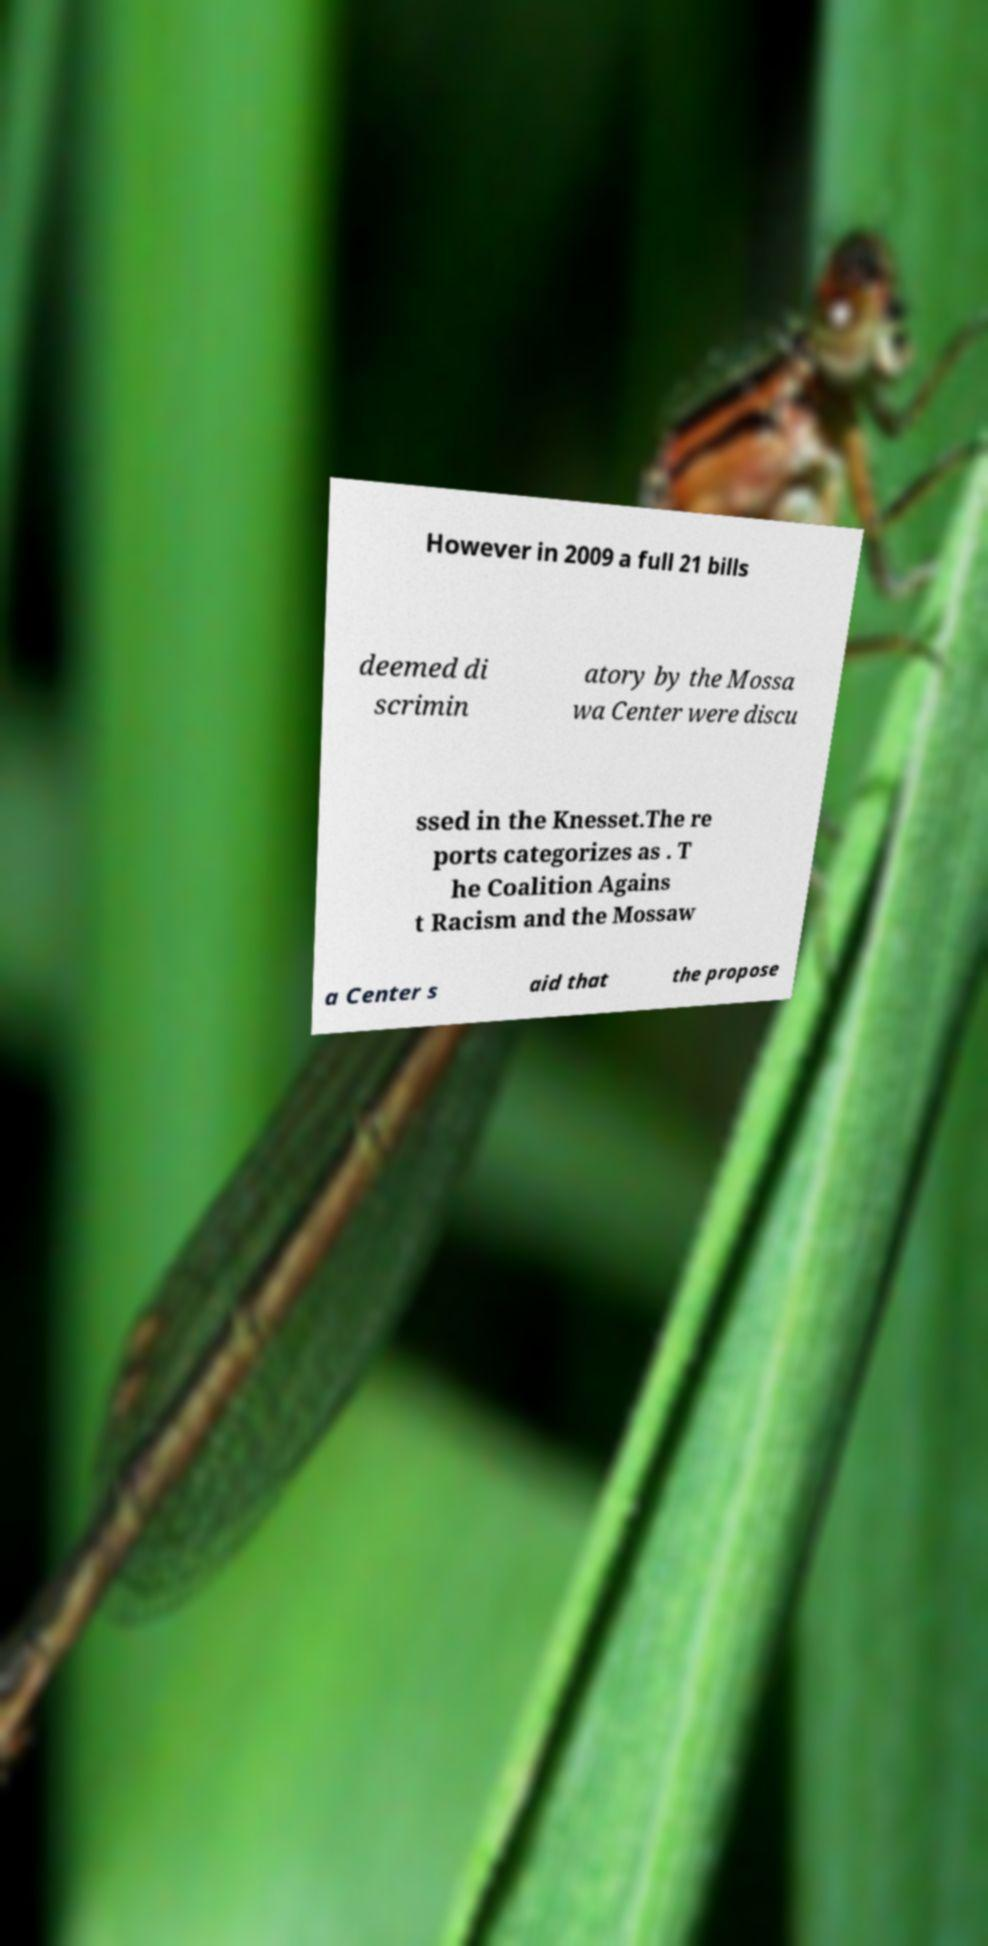For documentation purposes, I need the text within this image transcribed. Could you provide that? However in 2009 a full 21 bills deemed di scrimin atory by the Mossa wa Center were discu ssed in the Knesset.The re ports categorizes as . T he Coalition Agains t Racism and the Mossaw a Center s aid that the propose 